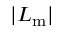Convert formula to latex. <formula><loc_0><loc_0><loc_500><loc_500>| L _ { m } |</formula> 